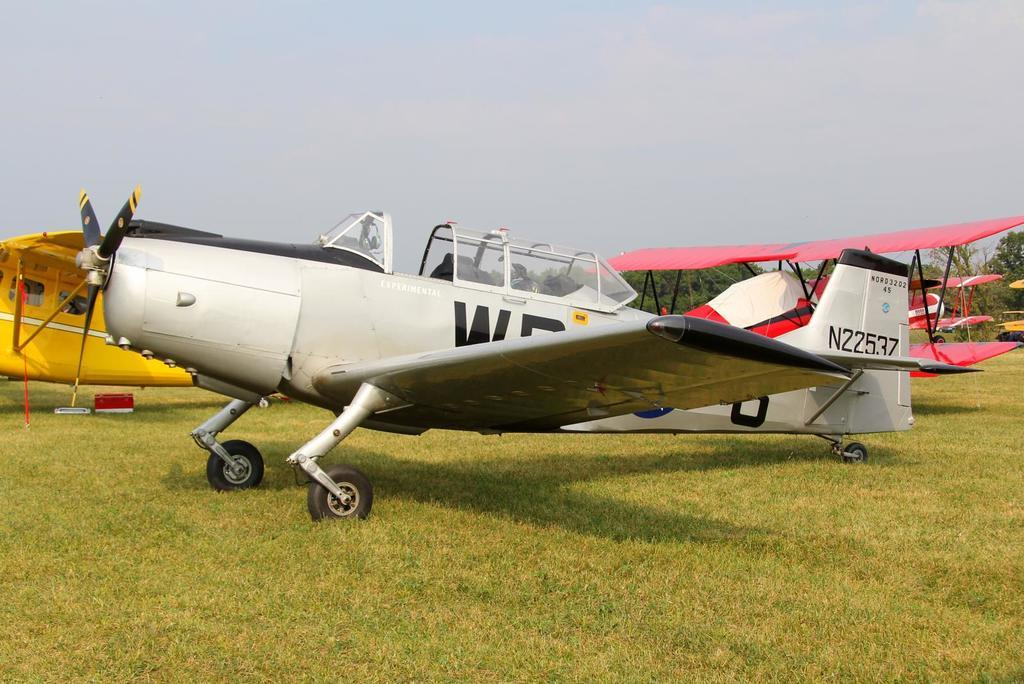<image>
Describe the image concisely. A plane with N22537 painted on its tail. 